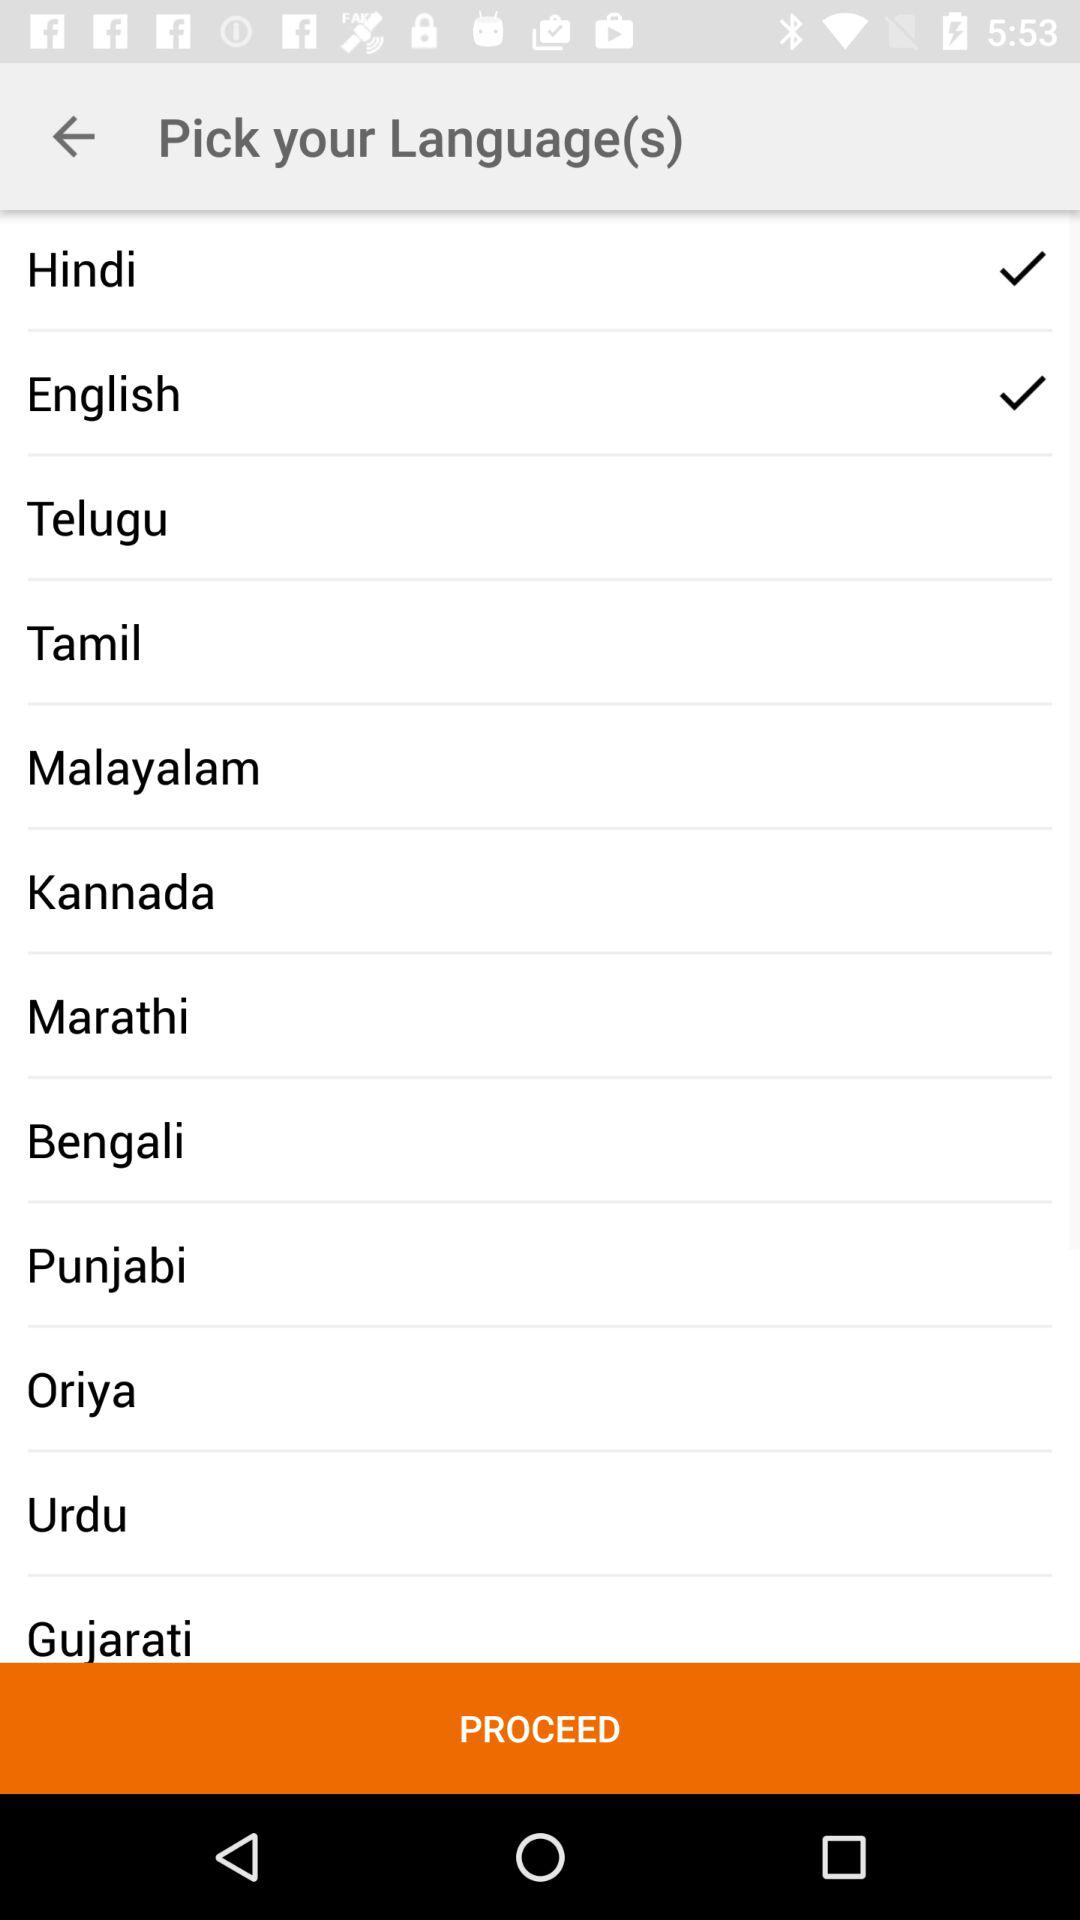What is the selected language? The selected languages are Hindi and English. 